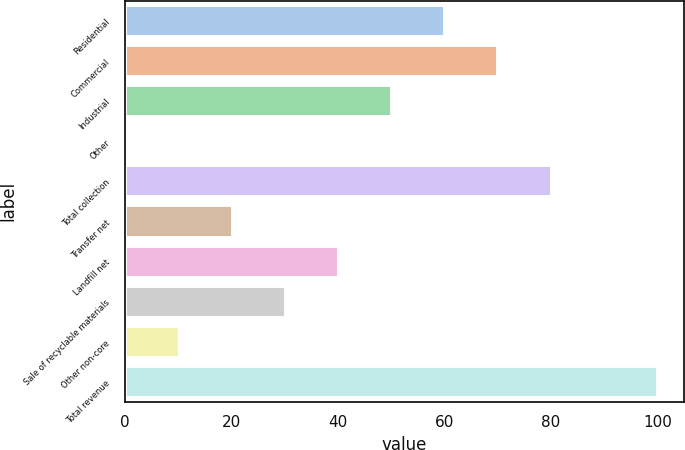<chart> <loc_0><loc_0><loc_500><loc_500><bar_chart><fcel>Residential<fcel>Commercial<fcel>Industrial<fcel>Other<fcel>Total collection<fcel>Transfer net<fcel>Landfill net<fcel>Sale of recyclable materials<fcel>Other non-core<fcel>Total revenue<nl><fcel>60.16<fcel>70.12<fcel>50.2<fcel>0.4<fcel>80.08<fcel>20.32<fcel>40.24<fcel>30.28<fcel>10.36<fcel>100<nl></chart> 